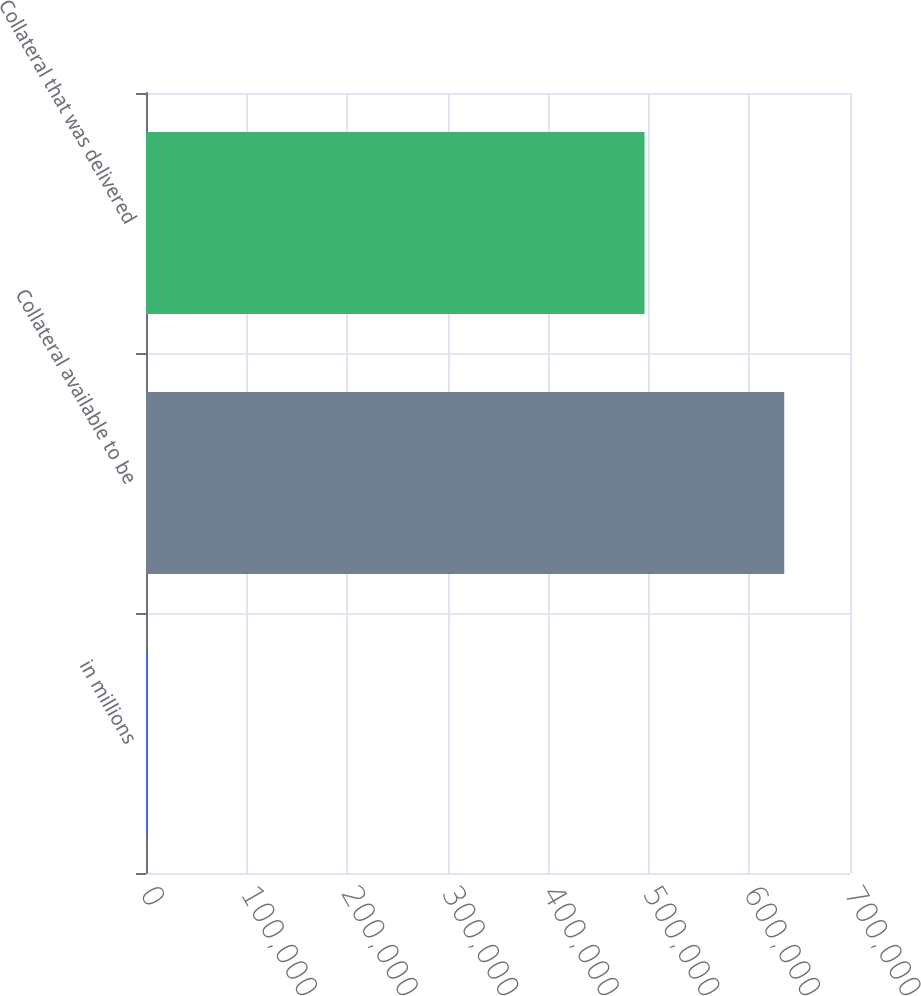<chart> <loc_0><loc_0><loc_500><loc_500><bar_chart><fcel>in millions<fcel>Collateral available to be<fcel>Collateral that was delivered<nl><fcel>2016<fcel>634609<fcel>495717<nl></chart> 